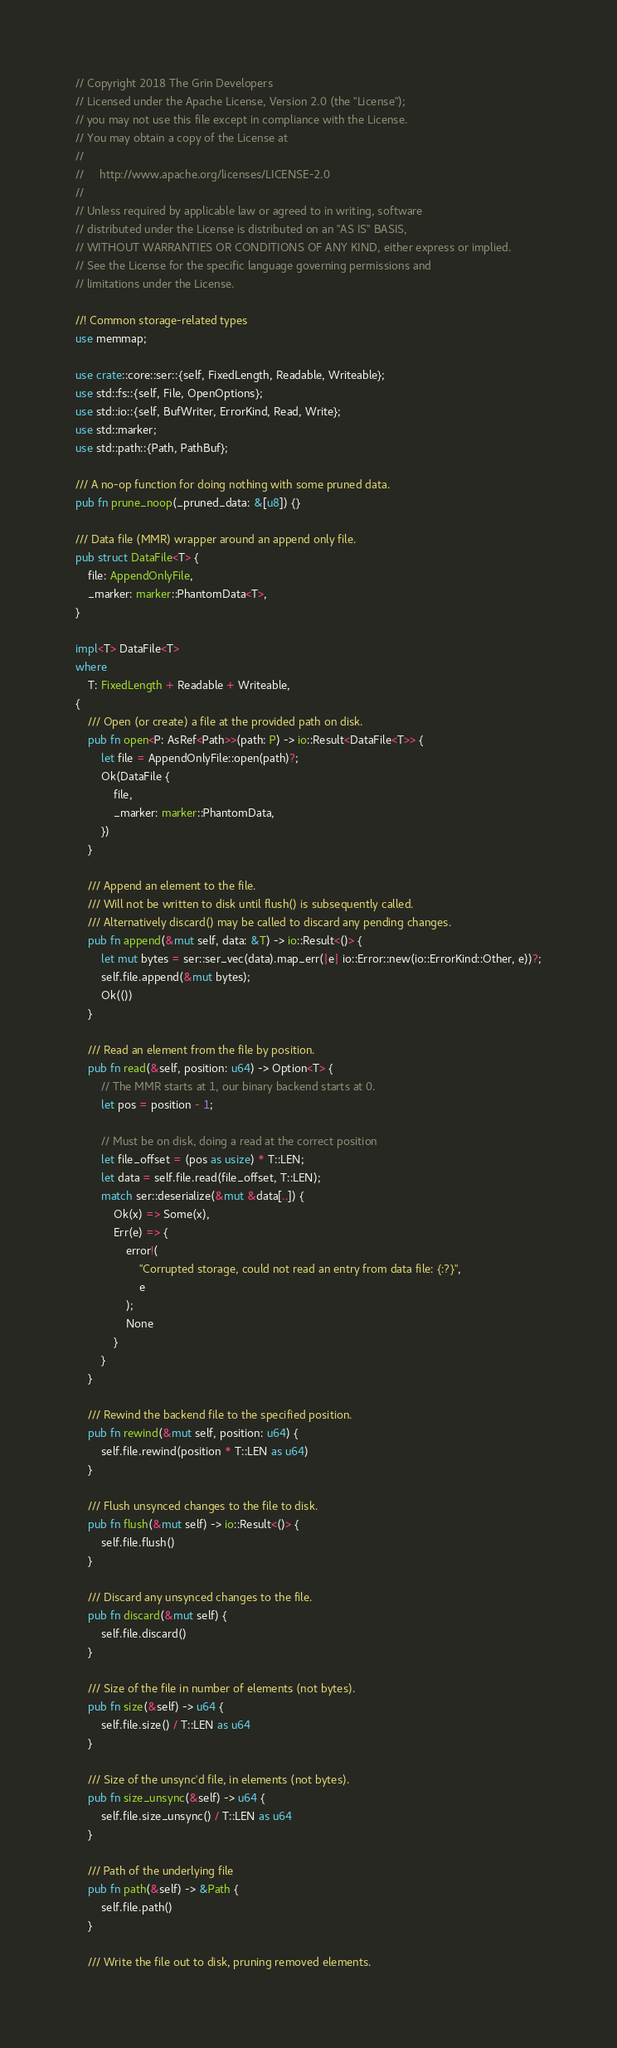<code> <loc_0><loc_0><loc_500><loc_500><_Rust_>// Copyright 2018 The Grin Developers
// Licensed under the Apache License, Version 2.0 (the "License");
// you may not use this file except in compliance with the License.
// You may obtain a copy of the License at
//
//     http://www.apache.org/licenses/LICENSE-2.0
//
// Unless required by applicable law or agreed to in writing, software
// distributed under the License is distributed on an "AS IS" BASIS,
// WITHOUT WARRANTIES OR CONDITIONS OF ANY KIND, either express or implied.
// See the License for the specific language governing permissions and
// limitations under the License.

//! Common storage-related types
use memmap;

use crate::core::ser::{self, FixedLength, Readable, Writeable};
use std::fs::{self, File, OpenOptions};
use std::io::{self, BufWriter, ErrorKind, Read, Write};
use std::marker;
use std::path::{Path, PathBuf};

/// A no-op function for doing nothing with some pruned data.
pub fn prune_noop(_pruned_data: &[u8]) {}

/// Data file (MMR) wrapper around an append only file.
pub struct DataFile<T> {
	file: AppendOnlyFile,
	_marker: marker::PhantomData<T>,
}

impl<T> DataFile<T>
where
	T: FixedLength + Readable + Writeable,
{
	/// Open (or create) a file at the provided path on disk.
	pub fn open<P: AsRef<Path>>(path: P) -> io::Result<DataFile<T>> {
		let file = AppendOnlyFile::open(path)?;
		Ok(DataFile {
			file,
			_marker: marker::PhantomData,
		})
	}

	/// Append an element to the file.
	/// Will not be written to disk until flush() is subsequently called.
	/// Alternatively discard() may be called to discard any pending changes.
	pub fn append(&mut self, data: &T) -> io::Result<()> {
		let mut bytes = ser::ser_vec(data).map_err(|e| io::Error::new(io::ErrorKind::Other, e))?;
		self.file.append(&mut bytes);
		Ok(())
	}

	/// Read an element from the file by position.
	pub fn read(&self, position: u64) -> Option<T> {
		// The MMR starts at 1, our binary backend starts at 0.
		let pos = position - 1;

		// Must be on disk, doing a read at the correct position
		let file_offset = (pos as usize) * T::LEN;
		let data = self.file.read(file_offset, T::LEN);
		match ser::deserialize(&mut &data[..]) {
			Ok(x) => Some(x),
			Err(e) => {
				error!(
					"Corrupted storage, could not read an entry from data file: {:?}",
					e
				);
				None
			}
		}
	}

	/// Rewind the backend file to the specified position.
	pub fn rewind(&mut self, position: u64) {
		self.file.rewind(position * T::LEN as u64)
	}

	/// Flush unsynced changes to the file to disk.
	pub fn flush(&mut self) -> io::Result<()> {
		self.file.flush()
	}

	/// Discard any unsynced changes to the file.
	pub fn discard(&mut self) {
		self.file.discard()
	}

	/// Size of the file in number of elements (not bytes).
	pub fn size(&self) -> u64 {
		self.file.size() / T::LEN as u64
	}

	/// Size of the unsync'd file, in elements (not bytes).
	pub fn size_unsync(&self) -> u64 {
		self.file.size_unsync() / T::LEN as u64
	}

	/// Path of the underlying file
	pub fn path(&self) -> &Path {
		self.file.path()
	}

	/// Write the file out to disk, pruning removed elements.</code> 